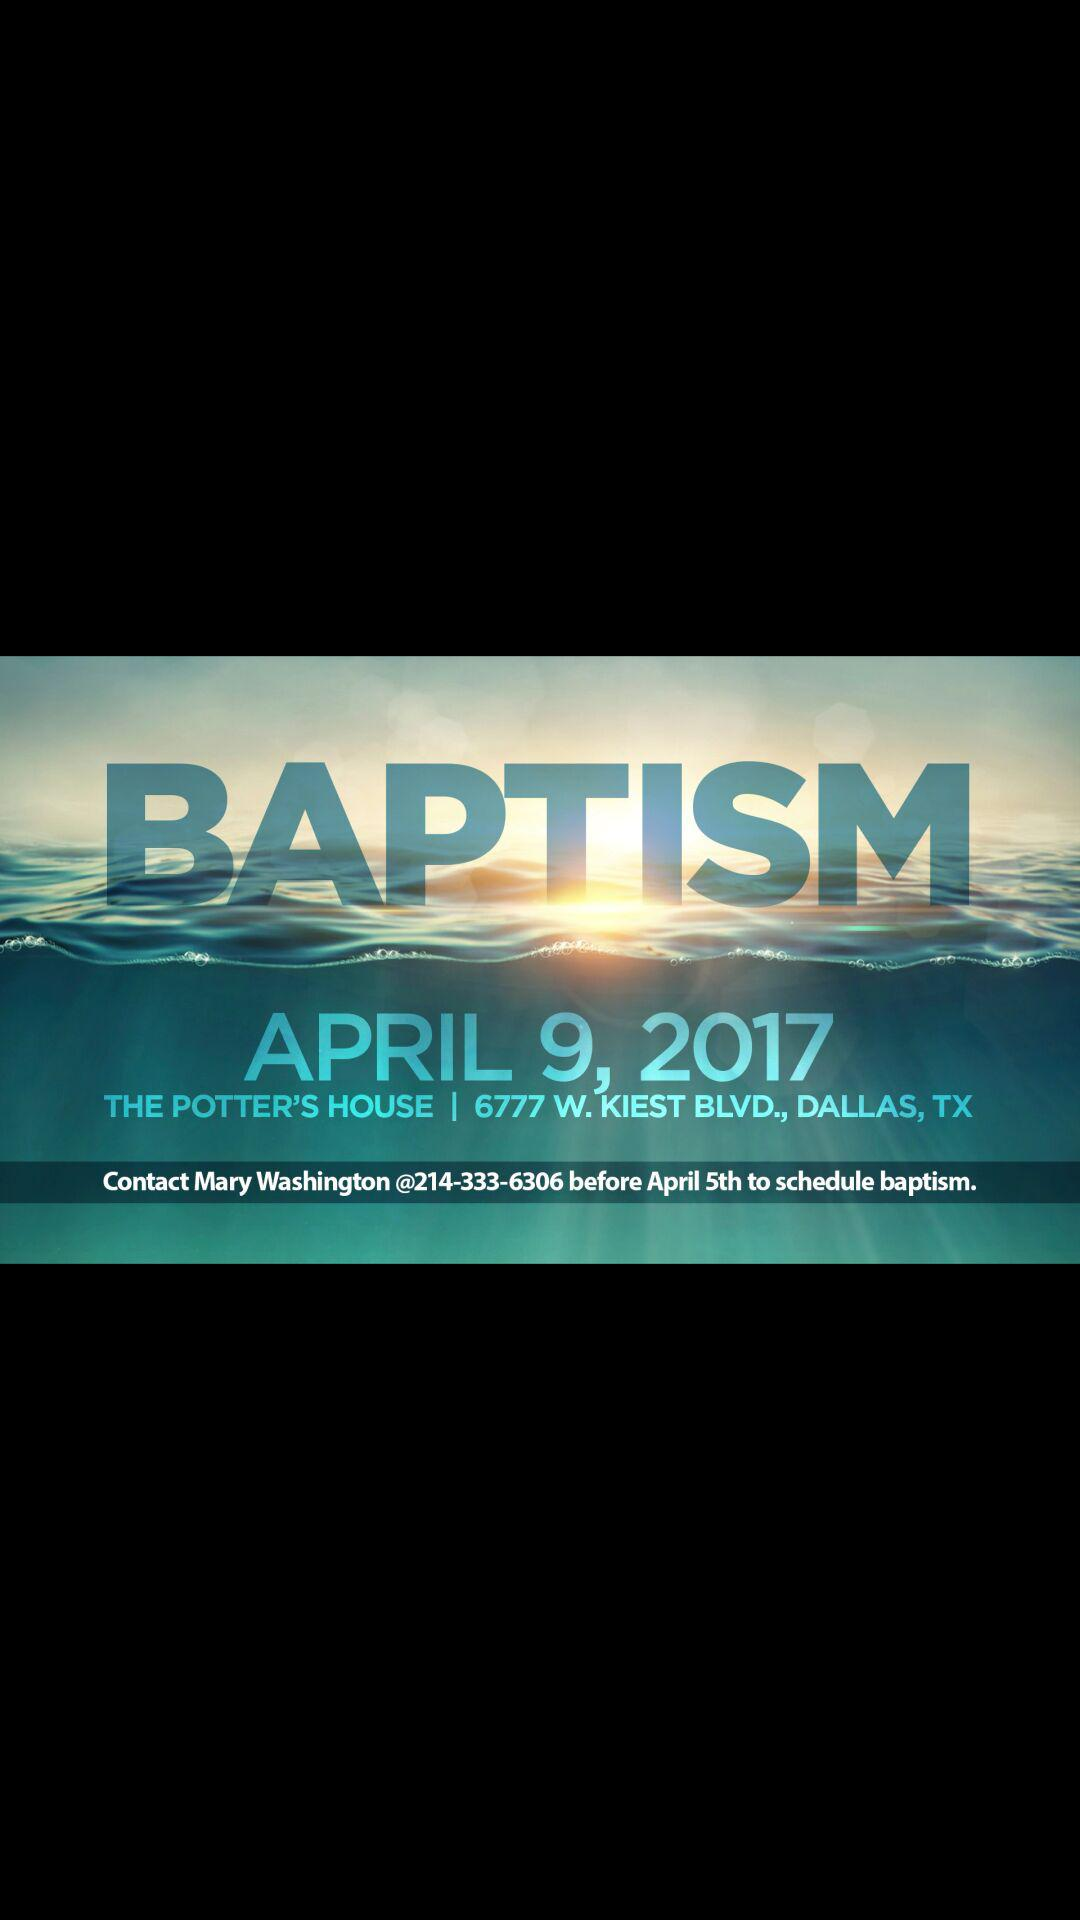What is the phone number of the person who can schedule a baptism?
Answer the question using a single word or phrase. 214-333-6306 